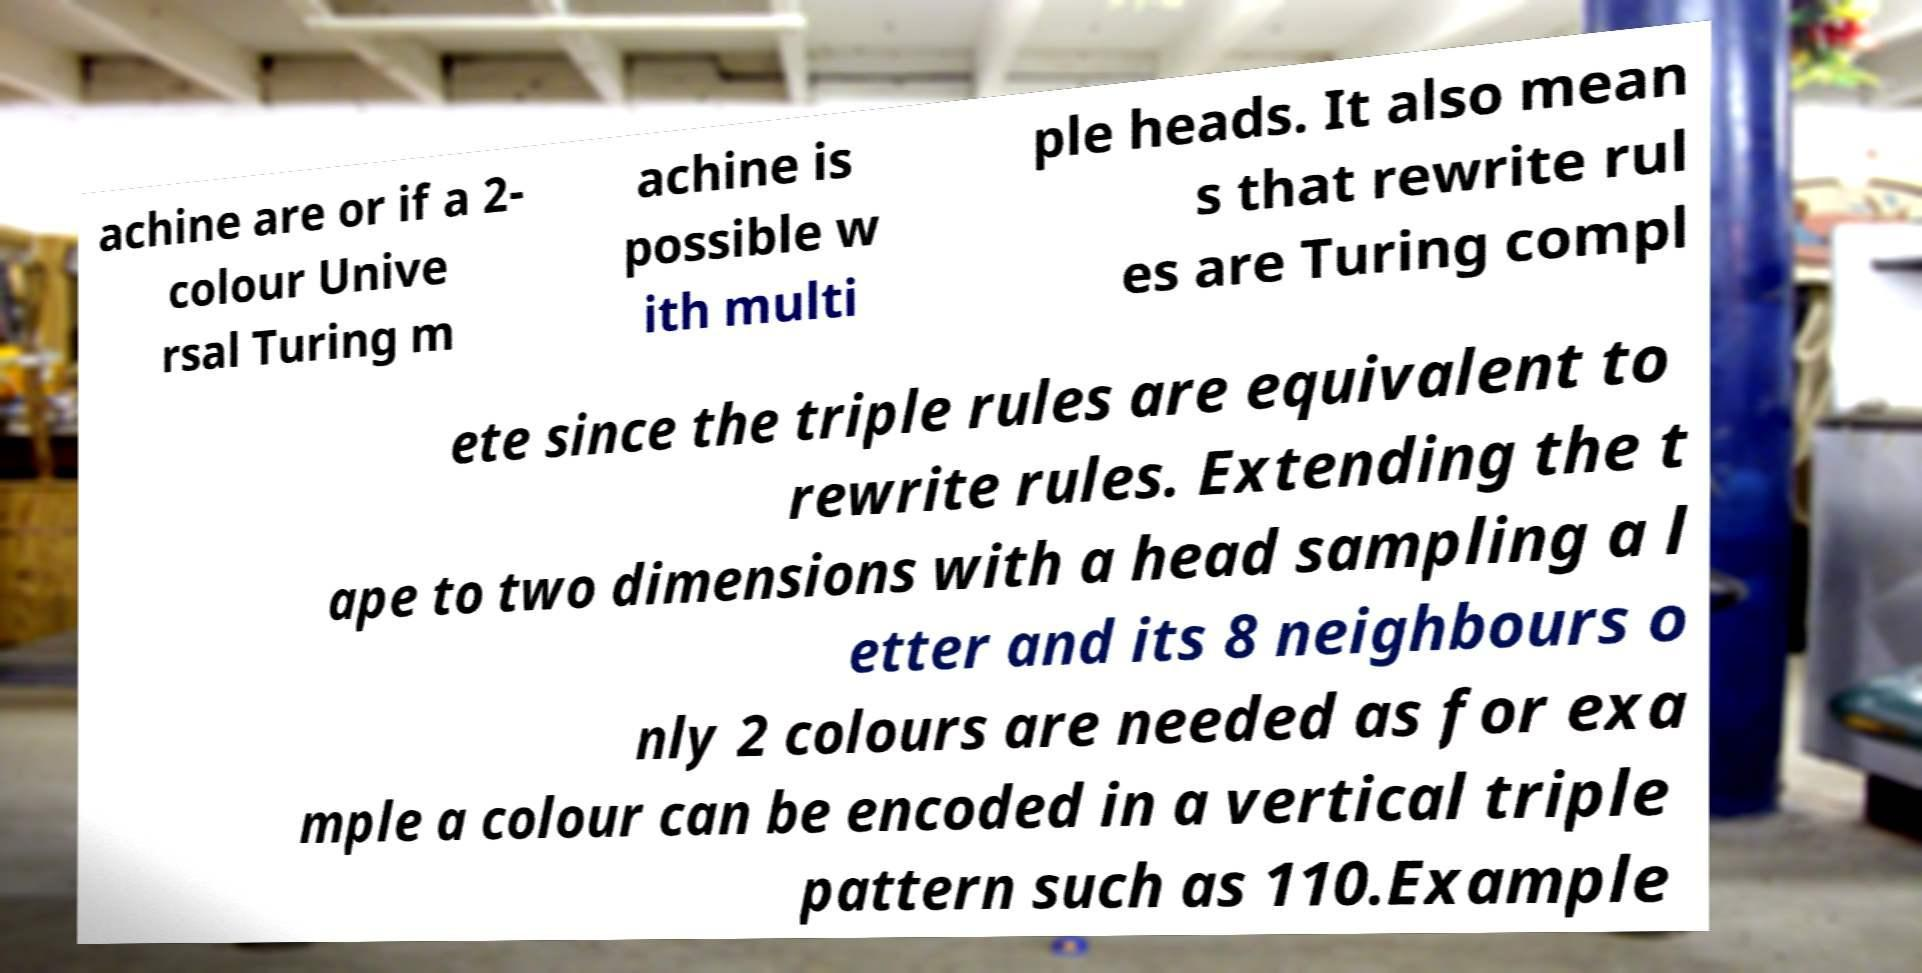There's text embedded in this image that I need extracted. Can you transcribe it verbatim? achine are or if a 2- colour Unive rsal Turing m achine is possible w ith multi ple heads. It also mean s that rewrite rul es are Turing compl ete since the triple rules are equivalent to rewrite rules. Extending the t ape to two dimensions with a head sampling a l etter and its 8 neighbours o nly 2 colours are needed as for exa mple a colour can be encoded in a vertical triple pattern such as 110.Example 